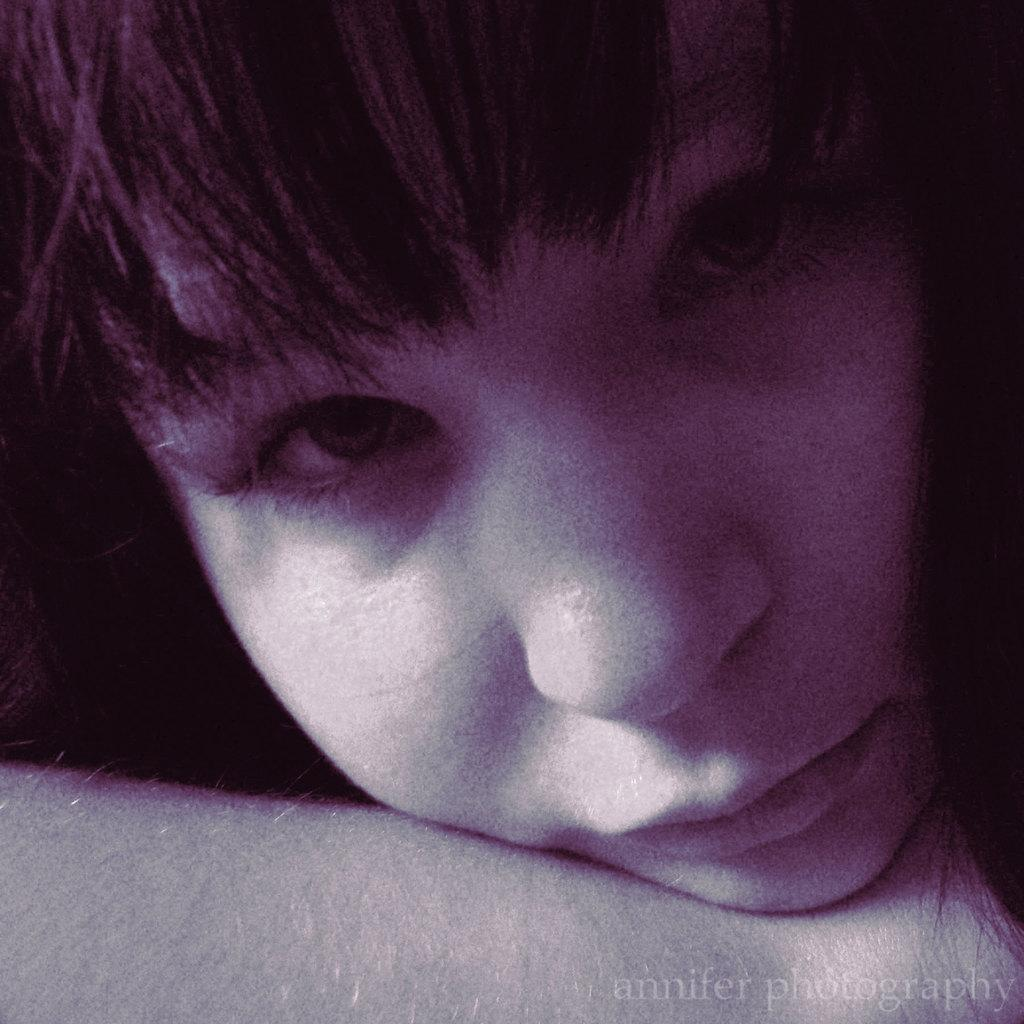What part of a person is visible in the image? There is a person's face visible in the image. What else can be seen in the image related to the person? There is a person's hand visible in the image. What type of station is depicted in the image? There is no station present in the image; it only features a person's face and hand. 